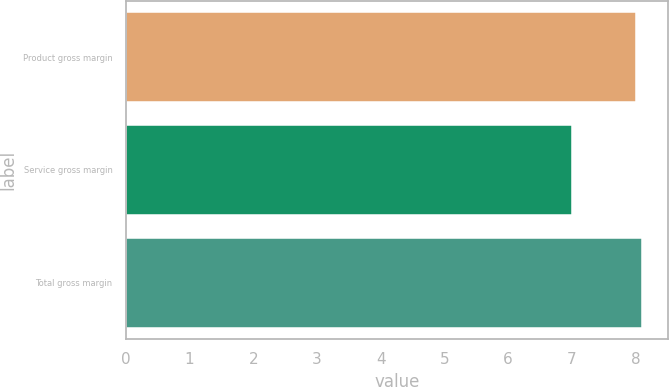<chart> <loc_0><loc_0><loc_500><loc_500><bar_chart><fcel>Product gross margin<fcel>Service gross margin<fcel>Total gross margin<nl><fcel>8<fcel>7<fcel>8.1<nl></chart> 